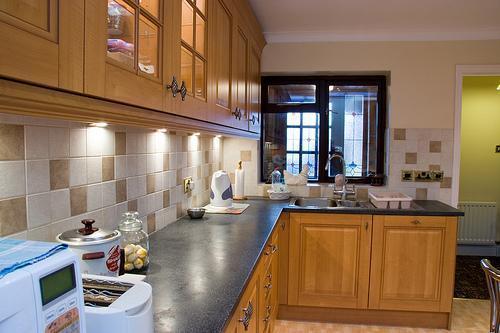How many electric kettles are there?
Give a very brief answer. 1. 